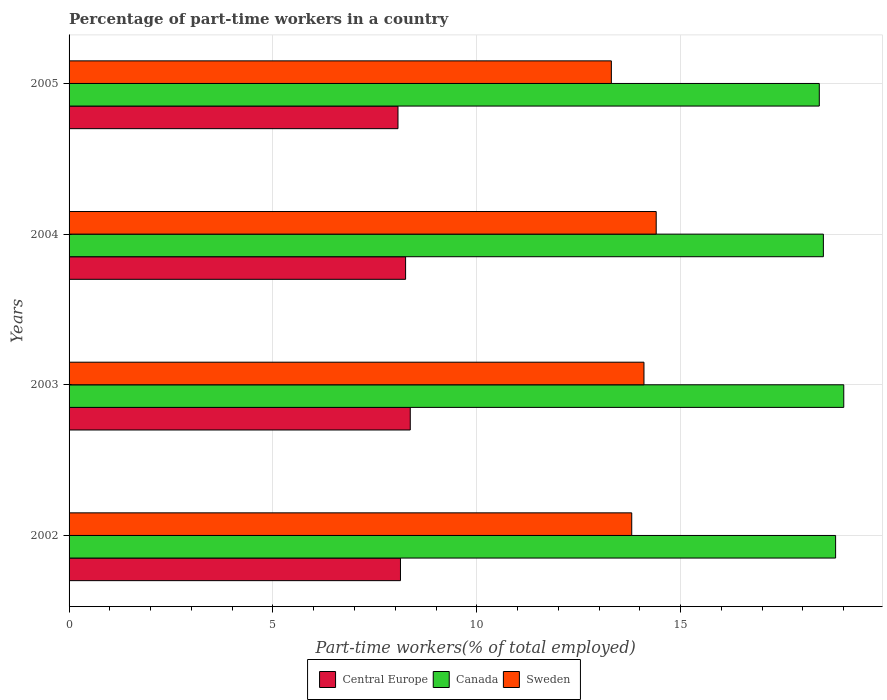How many different coloured bars are there?
Offer a very short reply. 3. Are the number of bars per tick equal to the number of legend labels?
Your response must be concise. Yes. Are the number of bars on each tick of the Y-axis equal?
Your answer should be compact. Yes. How many bars are there on the 2nd tick from the top?
Keep it short and to the point. 3. How many bars are there on the 1st tick from the bottom?
Your answer should be very brief. 3. What is the label of the 1st group of bars from the top?
Give a very brief answer. 2005. What is the percentage of part-time workers in Sweden in 2004?
Keep it short and to the point. 14.4. Across all years, what is the maximum percentage of part-time workers in Sweden?
Provide a short and direct response. 14.4. Across all years, what is the minimum percentage of part-time workers in Sweden?
Your answer should be compact. 13.3. In which year was the percentage of part-time workers in Sweden maximum?
Your answer should be very brief. 2004. In which year was the percentage of part-time workers in Canada minimum?
Offer a terse response. 2005. What is the total percentage of part-time workers in Central Europe in the graph?
Offer a terse response. 32.82. What is the difference between the percentage of part-time workers in Sweden in 2002 and that in 2005?
Your answer should be compact. 0.5. What is the difference between the percentage of part-time workers in Central Europe in 2005 and the percentage of part-time workers in Sweden in 2002?
Provide a short and direct response. -5.73. What is the average percentage of part-time workers in Central Europe per year?
Keep it short and to the point. 8.2. In the year 2005, what is the difference between the percentage of part-time workers in Canada and percentage of part-time workers in Sweden?
Ensure brevity in your answer.  5.1. What is the ratio of the percentage of part-time workers in Sweden in 2003 to that in 2005?
Your answer should be very brief. 1.06. Is the percentage of part-time workers in Central Europe in 2003 less than that in 2004?
Keep it short and to the point. No. Is the difference between the percentage of part-time workers in Canada in 2002 and 2005 greater than the difference between the percentage of part-time workers in Sweden in 2002 and 2005?
Your answer should be very brief. No. What is the difference between the highest and the second highest percentage of part-time workers in Central Europe?
Provide a short and direct response. 0.11. What is the difference between the highest and the lowest percentage of part-time workers in Central Europe?
Your answer should be very brief. 0.3. Is the sum of the percentage of part-time workers in Canada in 2002 and 2004 greater than the maximum percentage of part-time workers in Sweden across all years?
Provide a succinct answer. Yes. How many bars are there?
Make the answer very short. 12. Are the values on the major ticks of X-axis written in scientific E-notation?
Offer a terse response. No. How many legend labels are there?
Your answer should be very brief. 3. How are the legend labels stacked?
Your answer should be compact. Horizontal. What is the title of the graph?
Make the answer very short. Percentage of part-time workers in a country. Does "United Kingdom" appear as one of the legend labels in the graph?
Keep it short and to the point. No. What is the label or title of the X-axis?
Offer a terse response. Part-time workers(% of total employed). What is the label or title of the Y-axis?
Your answer should be compact. Years. What is the Part-time workers(% of total employed) of Central Europe in 2002?
Provide a succinct answer. 8.13. What is the Part-time workers(% of total employed) of Canada in 2002?
Your answer should be very brief. 18.8. What is the Part-time workers(% of total employed) in Sweden in 2002?
Your answer should be very brief. 13.8. What is the Part-time workers(% of total employed) of Central Europe in 2003?
Your answer should be compact. 8.37. What is the Part-time workers(% of total employed) in Canada in 2003?
Your answer should be compact. 19. What is the Part-time workers(% of total employed) in Sweden in 2003?
Provide a short and direct response. 14.1. What is the Part-time workers(% of total employed) in Central Europe in 2004?
Provide a short and direct response. 8.25. What is the Part-time workers(% of total employed) of Sweden in 2004?
Give a very brief answer. 14.4. What is the Part-time workers(% of total employed) in Central Europe in 2005?
Give a very brief answer. 8.07. What is the Part-time workers(% of total employed) in Canada in 2005?
Make the answer very short. 18.4. What is the Part-time workers(% of total employed) of Sweden in 2005?
Your answer should be very brief. 13.3. Across all years, what is the maximum Part-time workers(% of total employed) of Central Europe?
Your answer should be very brief. 8.37. Across all years, what is the maximum Part-time workers(% of total employed) in Sweden?
Ensure brevity in your answer.  14.4. Across all years, what is the minimum Part-time workers(% of total employed) in Central Europe?
Offer a very short reply. 8.07. Across all years, what is the minimum Part-time workers(% of total employed) in Canada?
Keep it short and to the point. 18.4. Across all years, what is the minimum Part-time workers(% of total employed) in Sweden?
Your answer should be very brief. 13.3. What is the total Part-time workers(% of total employed) in Central Europe in the graph?
Provide a succinct answer. 32.82. What is the total Part-time workers(% of total employed) in Canada in the graph?
Make the answer very short. 74.7. What is the total Part-time workers(% of total employed) in Sweden in the graph?
Provide a short and direct response. 55.6. What is the difference between the Part-time workers(% of total employed) of Central Europe in 2002 and that in 2003?
Your response must be concise. -0.24. What is the difference between the Part-time workers(% of total employed) in Sweden in 2002 and that in 2003?
Offer a very short reply. -0.3. What is the difference between the Part-time workers(% of total employed) of Central Europe in 2002 and that in 2004?
Keep it short and to the point. -0.13. What is the difference between the Part-time workers(% of total employed) of Sweden in 2002 and that in 2004?
Make the answer very short. -0.6. What is the difference between the Part-time workers(% of total employed) of Central Europe in 2002 and that in 2005?
Your answer should be compact. 0.06. What is the difference between the Part-time workers(% of total employed) of Canada in 2002 and that in 2005?
Your response must be concise. 0.4. What is the difference between the Part-time workers(% of total employed) in Sweden in 2002 and that in 2005?
Provide a succinct answer. 0.5. What is the difference between the Part-time workers(% of total employed) in Central Europe in 2003 and that in 2004?
Give a very brief answer. 0.11. What is the difference between the Part-time workers(% of total employed) in Canada in 2003 and that in 2004?
Your answer should be compact. 0.5. What is the difference between the Part-time workers(% of total employed) of Central Europe in 2003 and that in 2005?
Offer a terse response. 0.3. What is the difference between the Part-time workers(% of total employed) of Canada in 2003 and that in 2005?
Provide a short and direct response. 0.6. What is the difference between the Part-time workers(% of total employed) of Central Europe in 2004 and that in 2005?
Your answer should be very brief. 0.19. What is the difference between the Part-time workers(% of total employed) in Canada in 2004 and that in 2005?
Provide a succinct answer. 0.1. What is the difference between the Part-time workers(% of total employed) of Central Europe in 2002 and the Part-time workers(% of total employed) of Canada in 2003?
Offer a very short reply. -10.87. What is the difference between the Part-time workers(% of total employed) of Central Europe in 2002 and the Part-time workers(% of total employed) of Sweden in 2003?
Your response must be concise. -5.97. What is the difference between the Part-time workers(% of total employed) in Canada in 2002 and the Part-time workers(% of total employed) in Sweden in 2003?
Offer a very short reply. 4.7. What is the difference between the Part-time workers(% of total employed) of Central Europe in 2002 and the Part-time workers(% of total employed) of Canada in 2004?
Ensure brevity in your answer.  -10.37. What is the difference between the Part-time workers(% of total employed) in Central Europe in 2002 and the Part-time workers(% of total employed) in Sweden in 2004?
Provide a short and direct response. -6.27. What is the difference between the Part-time workers(% of total employed) of Canada in 2002 and the Part-time workers(% of total employed) of Sweden in 2004?
Your answer should be compact. 4.4. What is the difference between the Part-time workers(% of total employed) in Central Europe in 2002 and the Part-time workers(% of total employed) in Canada in 2005?
Provide a short and direct response. -10.27. What is the difference between the Part-time workers(% of total employed) in Central Europe in 2002 and the Part-time workers(% of total employed) in Sweden in 2005?
Your response must be concise. -5.17. What is the difference between the Part-time workers(% of total employed) in Central Europe in 2003 and the Part-time workers(% of total employed) in Canada in 2004?
Make the answer very short. -10.13. What is the difference between the Part-time workers(% of total employed) of Central Europe in 2003 and the Part-time workers(% of total employed) of Sweden in 2004?
Your response must be concise. -6.03. What is the difference between the Part-time workers(% of total employed) in Canada in 2003 and the Part-time workers(% of total employed) in Sweden in 2004?
Your answer should be compact. 4.6. What is the difference between the Part-time workers(% of total employed) of Central Europe in 2003 and the Part-time workers(% of total employed) of Canada in 2005?
Ensure brevity in your answer.  -10.03. What is the difference between the Part-time workers(% of total employed) in Central Europe in 2003 and the Part-time workers(% of total employed) in Sweden in 2005?
Your response must be concise. -4.93. What is the difference between the Part-time workers(% of total employed) of Central Europe in 2004 and the Part-time workers(% of total employed) of Canada in 2005?
Your answer should be compact. -10.15. What is the difference between the Part-time workers(% of total employed) of Central Europe in 2004 and the Part-time workers(% of total employed) of Sweden in 2005?
Your answer should be compact. -5.05. What is the difference between the Part-time workers(% of total employed) in Canada in 2004 and the Part-time workers(% of total employed) in Sweden in 2005?
Offer a terse response. 5.2. What is the average Part-time workers(% of total employed) of Central Europe per year?
Ensure brevity in your answer.  8.2. What is the average Part-time workers(% of total employed) in Canada per year?
Ensure brevity in your answer.  18.68. What is the average Part-time workers(% of total employed) of Sweden per year?
Ensure brevity in your answer.  13.9. In the year 2002, what is the difference between the Part-time workers(% of total employed) in Central Europe and Part-time workers(% of total employed) in Canada?
Offer a very short reply. -10.67. In the year 2002, what is the difference between the Part-time workers(% of total employed) of Central Europe and Part-time workers(% of total employed) of Sweden?
Ensure brevity in your answer.  -5.67. In the year 2003, what is the difference between the Part-time workers(% of total employed) of Central Europe and Part-time workers(% of total employed) of Canada?
Keep it short and to the point. -10.63. In the year 2003, what is the difference between the Part-time workers(% of total employed) of Central Europe and Part-time workers(% of total employed) of Sweden?
Offer a terse response. -5.73. In the year 2004, what is the difference between the Part-time workers(% of total employed) in Central Europe and Part-time workers(% of total employed) in Canada?
Your answer should be compact. -10.25. In the year 2004, what is the difference between the Part-time workers(% of total employed) in Central Europe and Part-time workers(% of total employed) in Sweden?
Offer a very short reply. -6.15. In the year 2005, what is the difference between the Part-time workers(% of total employed) of Central Europe and Part-time workers(% of total employed) of Canada?
Give a very brief answer. -10.33. In the year 2005, what is the difference between the Part-time workers(% of total employed) of Central Europe and Part-time workers(% of total employed) of Sweden?
Give a very brief answer. -5.23. In the year 2005, what is the difference between the Part-time workers(% of total employed) in Canada and Part-time workers(% of total employed) in Sweden?
Your answer should be very brief. 5.1. What is the ratio of the Part-time workers(% of total employed) of Central Europe in 2002 to that in 2003?
Your answer should be compact. 0.97. What is the ratio of the Part-time workers(% of total employed) of Canada in 2002 to that in 2003?
Offer a terse response. 0.99. What is the ratio of the Part-time workers(% of total employed) of Sweden in 2002 to that in 2003?
Your answer should be very brief. 0.98. What is the ratio of the Part-time workers(% of total employed) in Central Europe in 2002 to that in 2004?
Offer a very short reply. 0.98. What is the ratio of the Part-time workers(% of total employed) in Canada in 2002 to that in 2004?
Your answer should be very brief. 1.02. What is the ratio of the Part-time workers(% of total employed) in Central Europe in 2002 to that in 2005?
Give a very brief answer. 1.01. What is the ratio of the Part-time workers(% of total employed) of Canada in 2002 to that in 2005?
Your answer should be very brief. 1.02. What is the ratio of the Part-time workers(% of total employed) of Sweden in 2002 to that in 2005?
Keep it short and to the point. 1.04. What is the ratio of the Part-time workers(% of total employed) of Central Europe in 2003 to that in 2004?
Ensure brevity in your answer.  1.01. What is the ratio of the Part-time workers(% of total employed) in Canada in 2003 to that in 2004?
Your answer should be very brief. 1.03. What is the ratio of the Part-time workers(% of total employed) of Sweden in 2003 to that in 2004?
Keep it short and to the point. 0.98. What is the ratio of the Part-time workers(% of total employed) of Central Europe in 2003 to that in 2005?
Offer a very short reply. 1.04. What is the ratio of the Part-time workers(% of total employed) in Canada in 2003 to that in 2005?
Your answer should be compact. 1.03. What is the ratio of the Part-time workers(% of total employed) in Sweden in 2003 to that in 2005?
Ensure brevity in your answer.  1.06. What is the ratio of the Part-time workers(% of total employed) of Central Europe in 2004 to that in 2005?
Ensure brevity in your answer.  1.02. What is the ratio of the Part-time workers(% of total employed) in Canada in 2004 to that in 2005?
Provide a short and direct response. 1.01. What is the ratio of the Part-time workers(% of total employed) of Sweden in 2004 to that in 2005?
Ensure brevity in your answer.  1.08. What is the difference between the highest and the second highest Part-time workers(% of total employed) in Central Europe?
Keep it short and to the point. 0.11. What is the difference between the highest and the second highest Part-time workers(% of total employed) of Canada?
Make the answer very short. 0.2. What is the difference between the highest and the second highest Part-time workers(% of total employed) in Sweden?
Offer a terse response. 0.3. What is the difference between the highest and the lowest Part-time workers(% of total employed) of Central Europe?
Keep it short and to the point. 0.3. What is the difference between the highest and the lowest Part-time workers(% of total employed) of Canada?
Offer a terse response. 0.6. What is the difference between the highest and the lowest Part-time workers(% of total employed) in Sweden?
Keep it short and to the point. 1.1. 